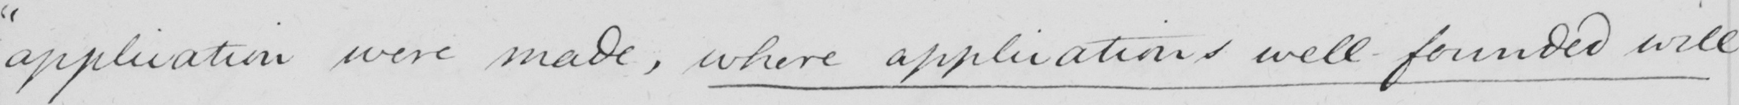What is written in this line of handwriting? " application were made , where applications well-founded will 